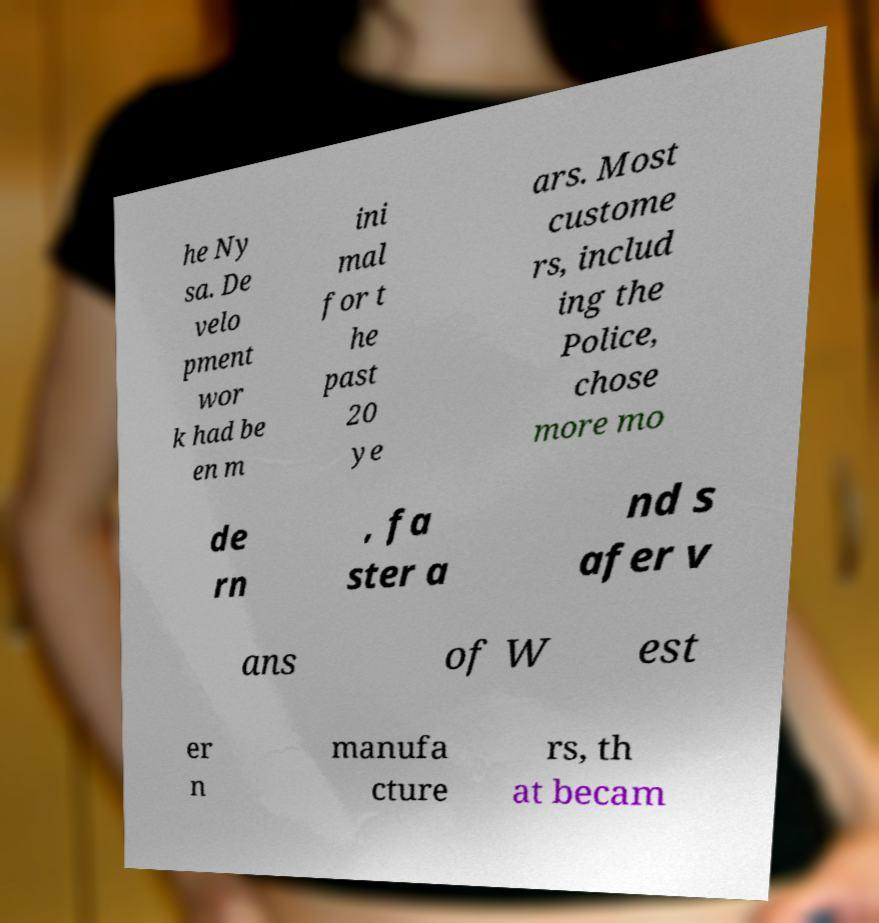For documentation purposes, I need the text within this image transcribed. Could you provide that? he Ny sa. De velo pment wor k had be en m ini mal for t he past 20 ye ars. Most custome rs, includ ing the Police, chose more mo de rn , fa ster a nd s afer v ans of W est er n manufa cture rs, th at becam 